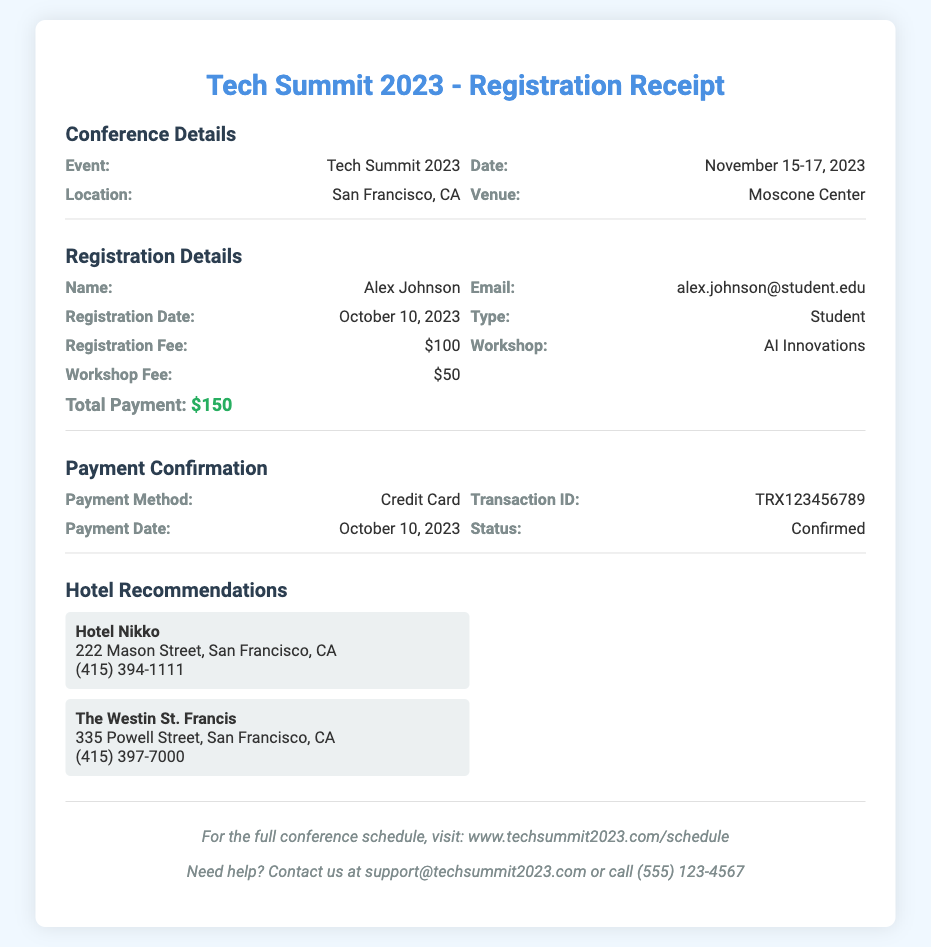What is the name of the event? The name of the event is specified in the document under Conference Details.
Answer: Tech Summit 2023 What is the registration fee? The registration fee is mentioned in the Registration Details section.
Answer: $100 Who is the registered attendee? The registered attendee's name is listed in the Registration Details section.
Answer: Alex Johnson What is the transaction ID for the payment? The transaction ID is found in the Payment Confirmation section.
Answer: TRX123456789 What is the total payment amount? The total payment is calculated by adding the registration fee and workshop fee, indicated in the Registration Details.
Answer: $150 What workshop is being attended? The specific workshop attended is provided in the Registration Details.
Answer: AI Innovations When was the registration completed? The date of registration can be found in the Registration Details section.
Answer: October 10, 2023 Where is the event located? The location of the event is detailed in the Conference Details section.
Answer: San Francisco, CA What payment method was used? The payment method is specified in the Payment Confirmation section.
Answer: Credit Card 